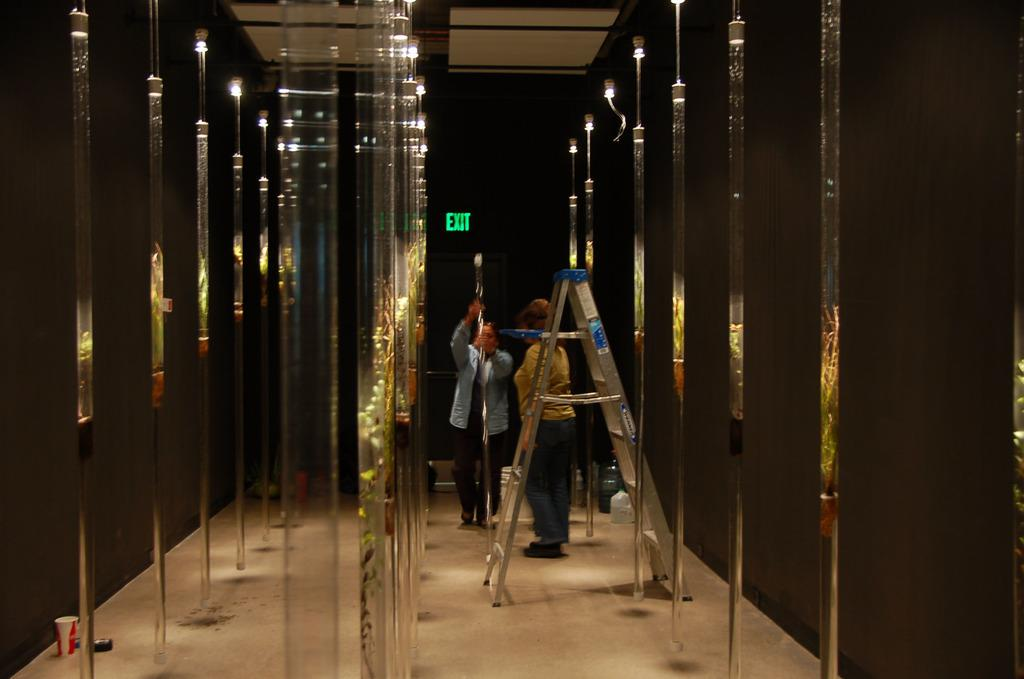<image>
Give a short and clear explanation of the subsequent image. Green exit sign behind a man and woman 